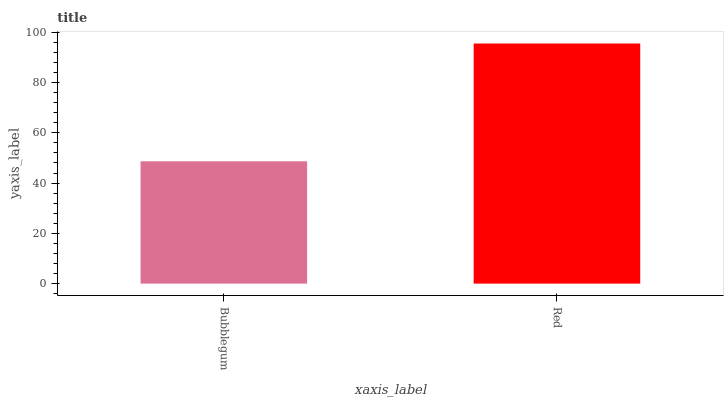Is Bubblegum the minimum?
Answer yes or no. Yes. Is Red the maximum?
Answer yes or no. Yes. Is Red the minimum?
Answer yes or no. No. Is Red greater than Bubblegum?
Answer yes or no. Yes. Is Bubblegum less than Red?
Answer yes or no. Yes. Is Bubblegum greater than Red?
Answer yes or no. No. Is Red less than Bubblegum?
Answer yes or no. No. Is Red the high median?
Answer yes or no. Yes. Is Bubblegum the low median?
Answer yes or no. Yes. Is Bubblegum the high median?
Answer yes or no. No. Is Red the low median?
Answer yes or no. No. 